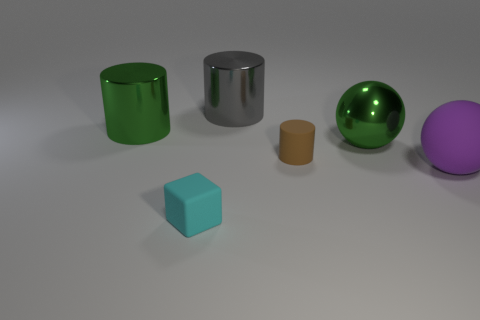What color is the tiny matte object that is the same shape as the big gray object?
Provide a short and direct response. Brown. There is a green thing on the left side of the small rubber object on the right side of the small cyan object; how many cyan rubber things are in front of it?
Provide a succinct answer. 1. Is the number of large green things on the right side of the brown cylinder less than the number of balls?
Make the answer very short. Yes. There is a gray metallic thing that is the same shape as the small brown rubber thing; what is its size?
Make the answer very short. Large. How many large cylinders have the same material as the large gray object?
Your response must be concise. 1. Does the purple thing on the right side of the brown cylinder have the same material as the big gray cylinder?
Offer a terse response. No. Are there the same number of small brown rubber things that are behind the gray metallic cylinder and big blue cylinders?
Your answer should be compact. Yes. The cyan object has what size?
Offer a terse response. Small. What number of metallic objects have the same color as the metal ball?
Your answer should be very brief. 1. Is the brown matte cylinder the same size as the cyan rubber object?
Offer a very short reply. Yes. 